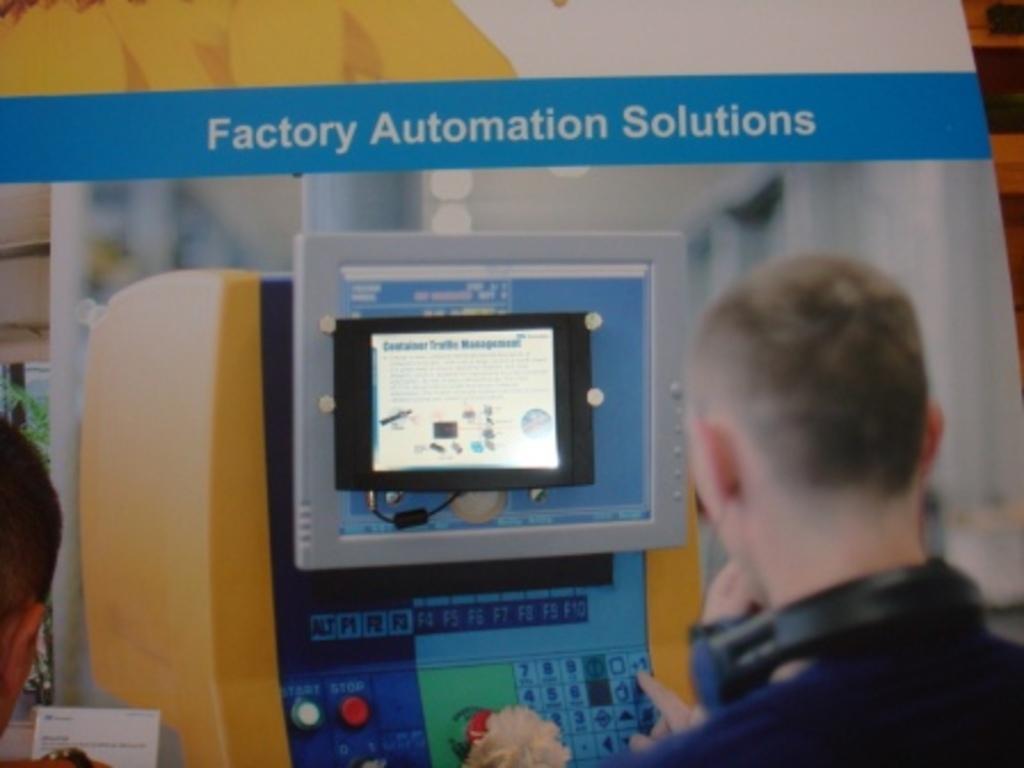Describe this image in one or two sentences. Here in this picture, in the middle we can see an electrical equipment present over there and on the top of it we can see a monitor present and in the front we can see couple of people standing over there and the person on the right side is wearing headset on him and behind it we can see a banner present over there. 